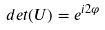<formula> <loc_0><loc_0><loc_500><loc_500>d e t ( U ) = e ^ { i 2 \varphi }</formula> 